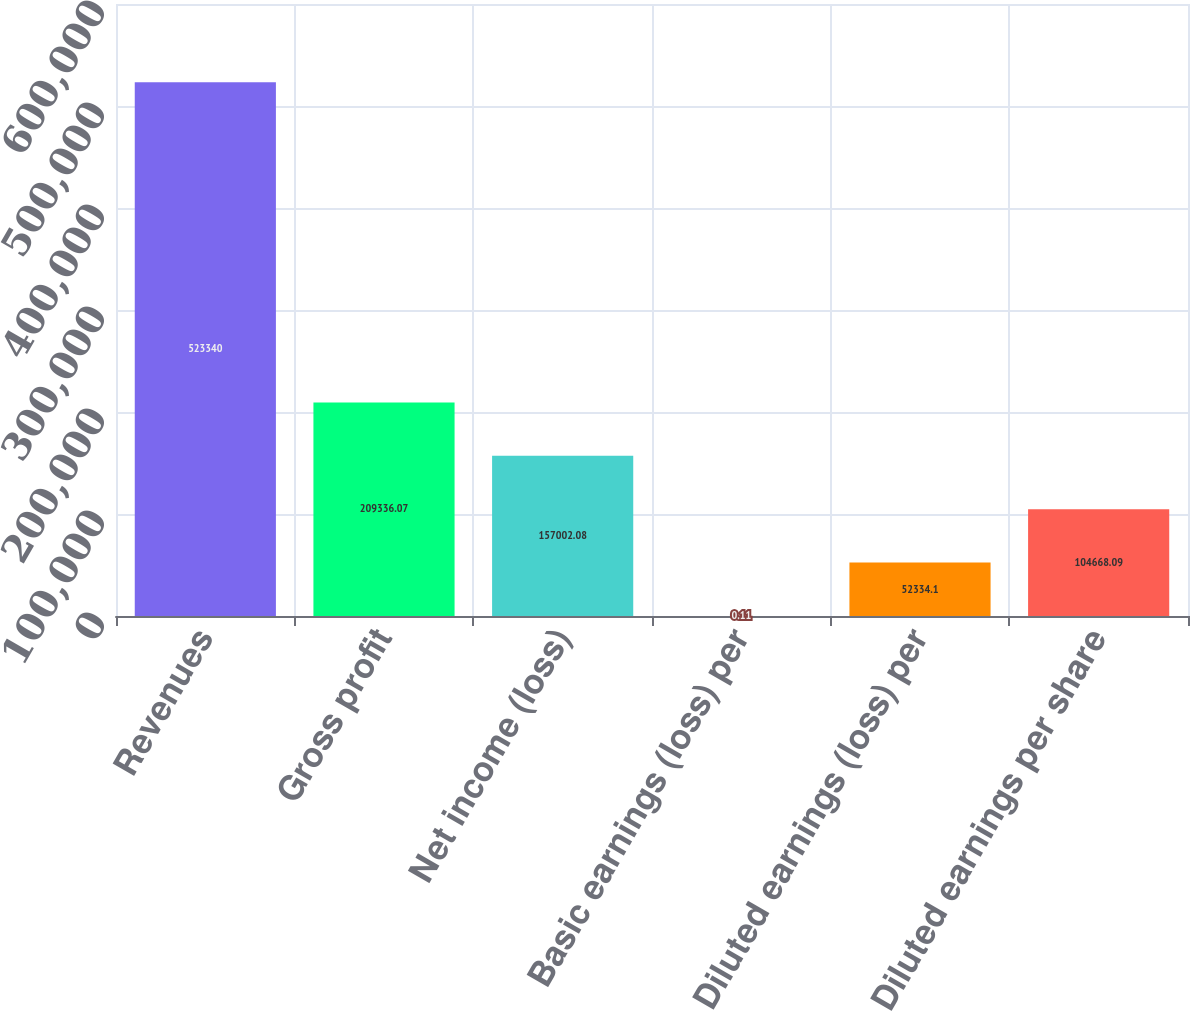Convert chart. <chart><loc_0><loc_0><loc_500><loc_500><bar_chart><fcel>Revenues<fcel>Gross profit<fcel>Net income (loss)<fcel>Basic earnings (loss) per<fcel>Diluted earnings (loss) per<fcel>Diluted earnings per share<nl><fcel>523340<fcel>209336<fcel>157002<fcel>0.11<fcel>52334.1<fcel>104668<nl></chart> 